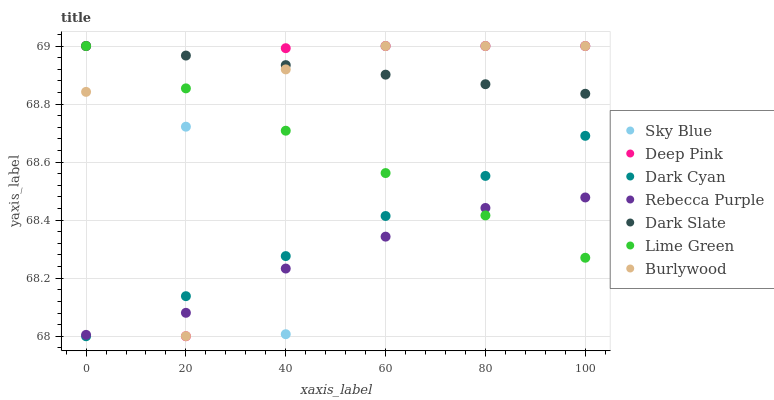Does Rebecca Purple have the minimum area under the curve?
Answer yes or no. Yes. Does Dark Slate have the maximum area under the curve?
Answer yes or no. Yes. Does Burlywood have the minimum area under the curve?
Answer yes or no. No. Does Burlywood have the maximum area under the curve?
Answer yes or no. No. Is Lime Green the smoothest?
Answer yes or no. Yes. Is Sky Blue the roughest?
Answer yes or no. Yes. Is Burlywood the smoothest?
Answer yes or no. No. Is Burlywood the roughest?
Answer yes or no. No. Does Dark Cyan have the lowest value?
Answer yes or no. Yes. Does Burlywood have the lowest value?
Answer yes or no. No. Does Lime Green have the highest value?
Answer yes or no. Yes. Does Rebecca Purple have the highest value?
Answer yes or no. No. Is Rebecca Purple less than Dark Slate?
Answer yes or no. Yes. Is Dark Slate greater than Dark Cyan?
Answer yes or no. Yes. Does Dark Cyan intersect Sky Blue?
Answer yes or no. Yes. Is Dark Cyan less than Sky Blue?
Answer yes or no. No. Is Dark Cyan greater than Sky Blue?
Answer yes or no. No. Does Rebecca Purple intersect Dark Slate?
Answer yes or no. No. 